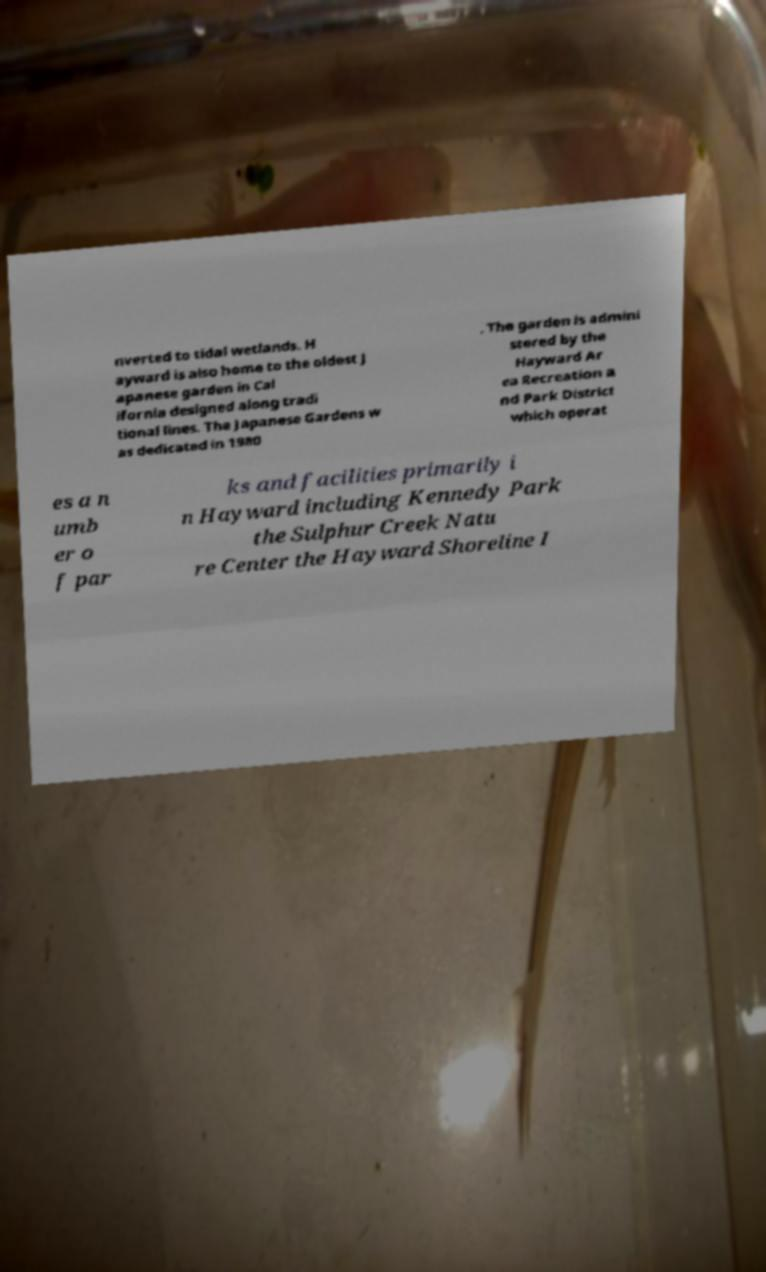Could you assist in decoding the text presented in this image and type it out clearly? nverted to tidal wetlands. H ayward is also home to the oldest J apanese garden in Cal ifornia designed along tradi tional lines. The Japanese Gardens w as dedicated in 1980 . The garden is admini stered by the Hayward Ar ea Recreation a nd Park District which operat es a n umb er o f par ks and facilities primarily i n Hayward including Kennedy Park the Sulphur Creek Natu re Center the Hayward Shoreline I 